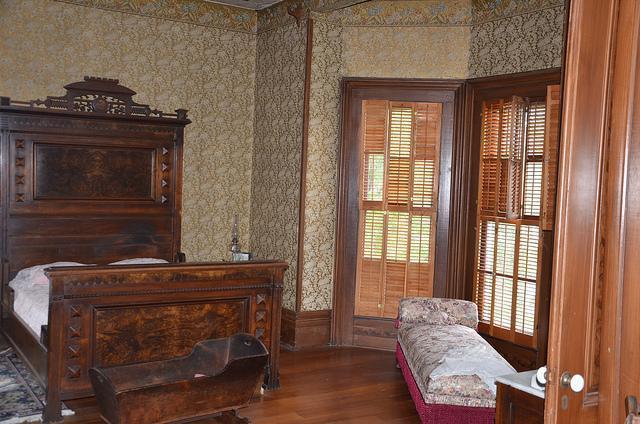How many beds are visible?
Give a very brief answer. 2. 